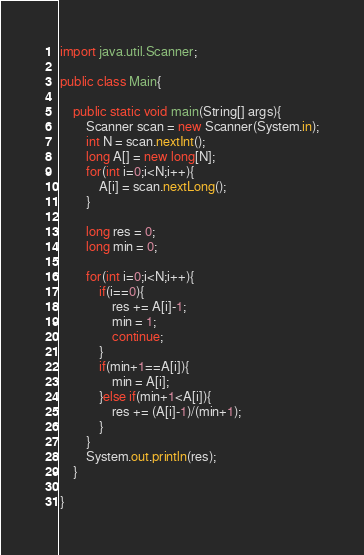<code> <loc_0><loc_0><loc_500><loc_500><_Java_>import java.util.Scanner;

public class Main{

	public static void main(String[] args){
		Scanner scan = new Scanner(System.in);
		int N = scan.nextInt();
		long A[] = new long[N];
		for(int i=0;i<N;i++){
			A[i] = scan.nextLong();
		}

		long res = 0;
		long min = 0;

		for(int i=0;i<N;i++){
			if(i==0){
				res += A[i]-1;
				min = 1;
				continue;
			}
			if(min+1==A[i]){
				min = A[i];
			}else if(min+1<A[i]){
				res += (A[i]-1)/(min+1);
			}
		}
		System.out.println(res);
	}

}</code> 